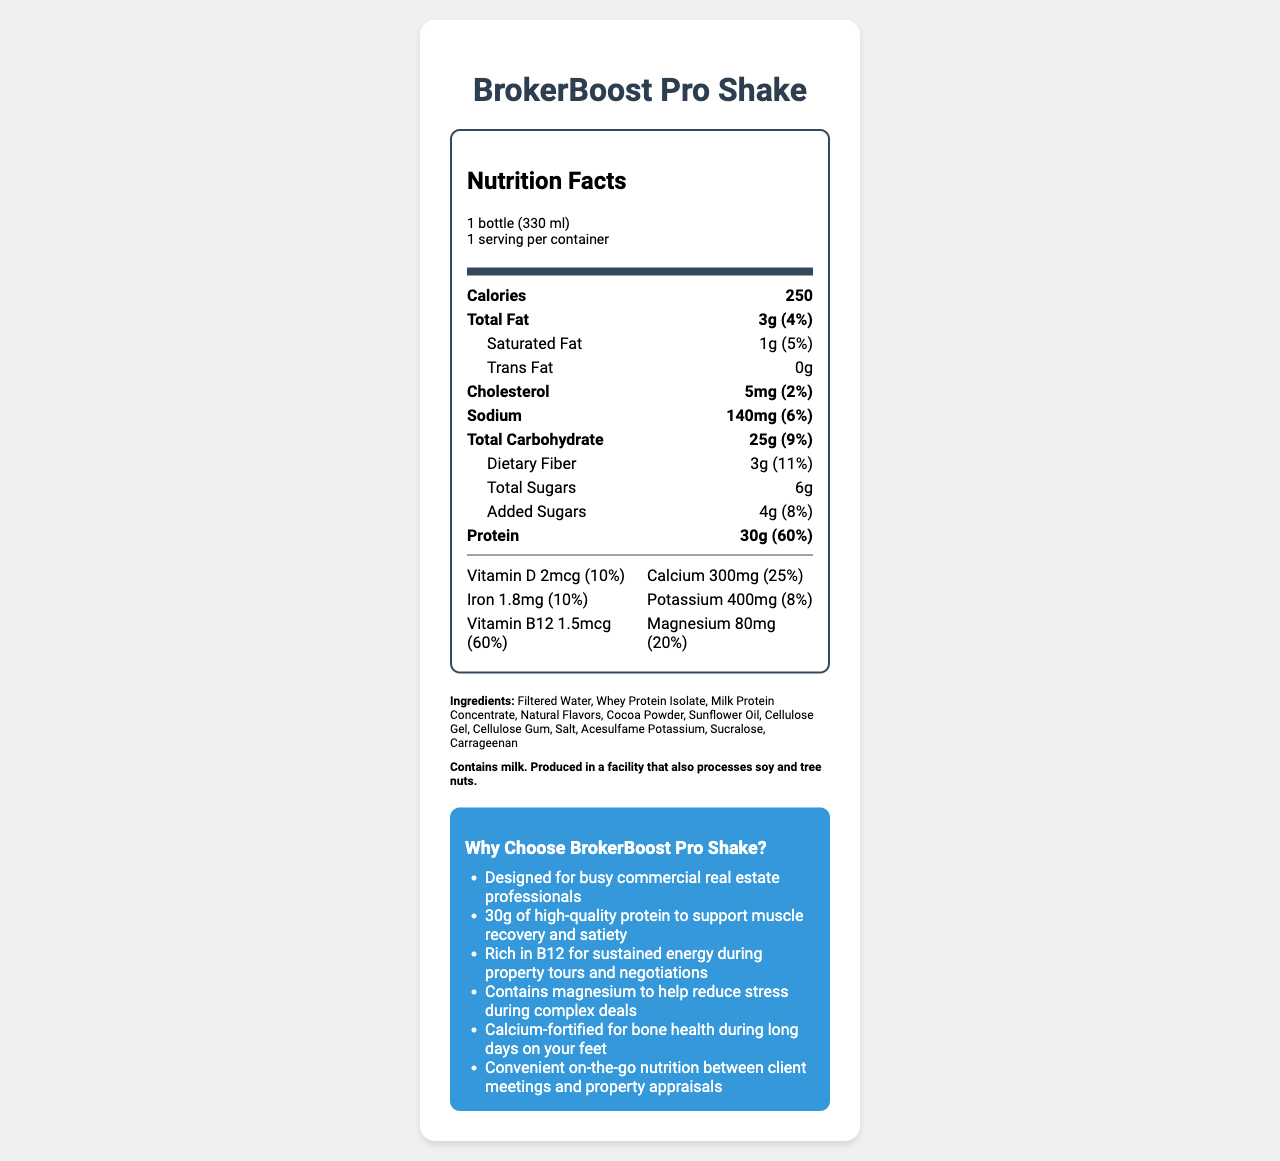how many calories does the BrokerBoost Pro Shake contain? The document states that the BrokerBoost Pro Shake contains 250 calories.
Answer: 250 what is the serving size for the BrokerBoost Pro Shake? The serving size is listed as "1 bottle (330 ml)".
Answer: 1 bottle (330 ml) how much protein is in one serving of the shake? The document states that one serving of the shake contains 30 grams of protein.
Answer: 30g what is the daily value percentage of dietary fiber in the shake? The daily value percentage for dietary fiber is listed as 11%.
Answer: 11% what are the total carbohydrates in one serving? The document indicates that there are 25 grams of total carbohydrates in one serving.
Answer: 25g which of the following marketing claims is made for the BrokerBoost Pro Shake? A. Supports bone health B. Low calorie C. Vegan-friendly The marketing claims state that the shake is "Calcium-fortified for bone health during long days on your feet".
Answer: A. Supports bone health what allergens are present in the BrokerBoost Pro Shake according to the document? A. Soy B. Tree nuts C. Milk D. All of the above The allergen information states "Contains milk. Produced in a facility that also processes soy and tree nuts," which implies milk is present.
Answer: C. Milk does the BrokerBoost Pro Shake contain any trans fat? The document states that the shake contains 0 grams of trans fat.
Answer: No is the shake high in protein? With 30 grams of protein per serving, which is 60% of the daily value, the shake can be considered high in protein.
Answer: Yes summarize the main information on the BrokerBoost Pro Shake's nutrition label. This summary captures the key nutritional content, ingredients, allergen information, and marketing claims for the BrokerBoost Pro Shake.
Answer: The BrokerBoost Pro Shake contains 250 calories per 330 ml bottle, with 3 grams of total fat, including 1 gram of saturated fat and 0 grams of trans fat. It has 5 mg of cholesterol, 140 mg of sodium, 25 grams of carbohydrates, including 3 grams of dietary fiber, 6 grams of total sugars, and 4 grams of added sugars. It contains 30 grams of protein. The shake also provides various vitamins and minerals, including vitamin D, calcium, iron, potassium, vitamin B12, and magnesium. The ingredients include filtered water, whey protein isolate, and several others. The product contains milk and may contain traces of soy and tree nuts. It's marketed to support busy commercial real estate professionals with claims for muscle recovery, sustained energy, stress reduction, and bone health. how much iron does the shake provide per serving? The document lists that the shake provides 1.8 milligrams of iron per serving.
Answer: 1.8mg what is one of the key benefits of vitamin B12 in the shake as per the marketing claims? The marketing claims mention that the shake is "Rich in B12 for sustained energy during property tours and negotiations".
Answer: Sustained energy during property tours and negotiations list one ingredient that is used as a sweetener in the shake. The ingredients list includes Sucralose, which is a sweetener.
Answer: Sucralose can the exact price of the BrokerBoost Pro Shake be determined from the document? The document does not provide any information regarding the price of the shake.
Answer: Cannot be determined what percentage of the daily value for magnesium does the shake provide? The shake provides 20% of the daily value for magnesium.
Answer: 20% is this drink suitable for people with a lactose intolerance? The document states that the shake contains milk, which is not suitable for individuals with lactose intolerance.
Answer: No 